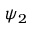Convert formula to latex. <formula><loc_0><loc_0><loc_500><loc_500>\psi _ { 2 }</formula> 